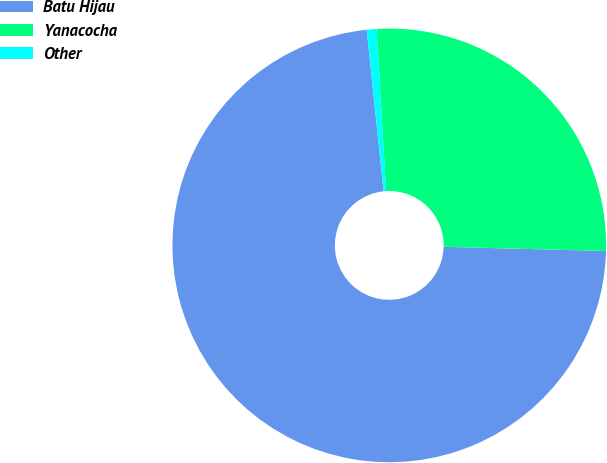Convert chart to OTSL. <chart><loc_0><loc_0><loc_500><loc_500><pie_chart><fcel>Batu Hijau<fcel>Yanacocha<fcel>Other<nl><fcel>72.93%<fcel>26.34%<fcel>0.73%<nl></chart> 